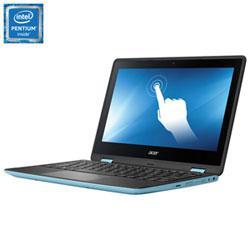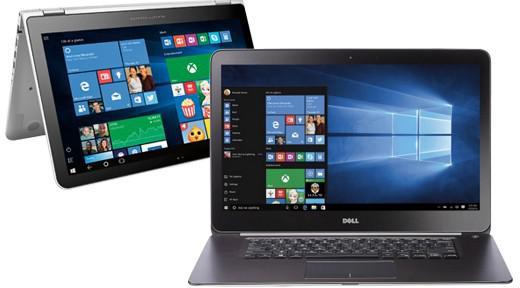The first image is the image on the left, the second image is the image on the right. For the images shown, is this caption "Human hands are near a keyboard in one image." true? Answer yes or no. No. The first image is the image on the left, the second image is the image on the right. Considering the images on both sides, is "There is at least one human hand that is at least partially visible" valid? Answer yes or no. No. 